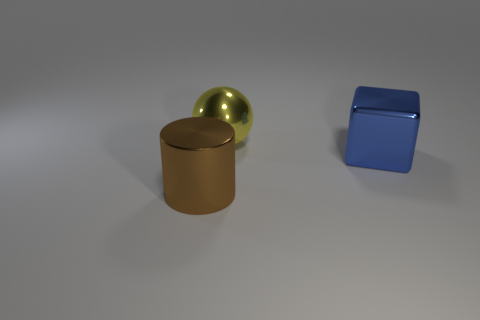Add 3 cyan spheres. How many objects exist? 6 Subtract all spheres. How many objects are left? 2 Subtract 1 yellow balls. How many objects are left? 2 Subtract all big brown cylinders. Subtract all cylinders. How many objects are left? 1 Add 2 large spheres. How many large spheres are left? 3 Add 1 big yellow metallic things. How many big yellow metallic things exist? 2 